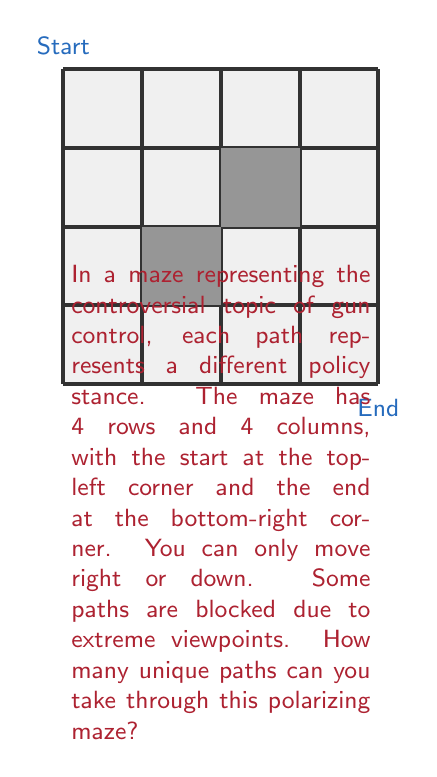What is the answer to this math problem? Let's approach this step-by-step:

1) First, we need to understand that in a 4x4 grid without any blocks, the number of unique paths would be $\binom{6}{3} = 20$, as we need to make 3 right moves and 3 down moves in any order.

2) However, we have two blocked squares in this maze. We need to subtract the number of paths that would go through these blocked squares.

3) For the upper blocked square (1,2):
   - To reach this square: $\binom{3}{1} = 3$ ways
   - From this square to the end: $\binom{4}{2} = 6$ ways
   - Total paths through this square: $3 * 6 = 18$

4) For the lower blocked square (2,1):
   - To reach this square: $\binom{3}{2} = 3$ ways
   - From this square to the end: $\binom{4}{2} = 6$ ways
   - Total paths through this square: $3 * 6 = 18$

5) However, we've double-counted the paths that go through both blocked squares. We need to add these back:
   - To reach (1,1): $\binom{2}{1} = 2$ ways
   - From (1,1) to (3,3): $\binom{4}{2} = 6$ ways
   - Total double-counted paths: $2 * 6 = 12$

6) Therefore, the total number of unique paths is:
   $$20 - 18 - 18 + 12 = -4$$

7) However, we can't have a negative number of paths. This means all paths are blocked, and there are 0 unique paths through the maze.

This result metaphorically represents how extreme polarization in the gun control debate can lead to policy gridlock, where no viable paths forward exist.
Answer: 0 